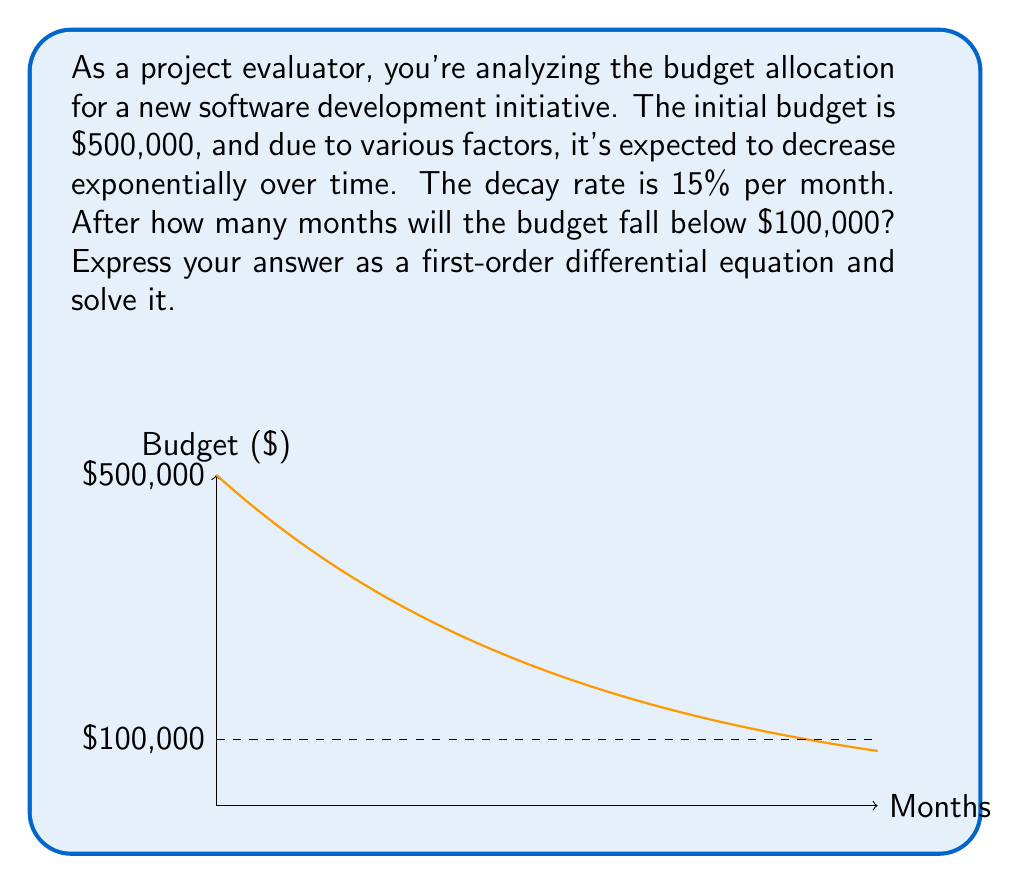Teach me how to tackle this problem. Let's approach this step-by-step:

1) Let $B(t)$ be the budget at time $t$ (in months). We know that $B(0) = 500,000$.

2) The rate of change of the budget is proportional to the current budget, with a decay rate of 15% per month. This can be expressed as a differential equation:

   $$\frac{dB}{dt} = -0.15B$$

3) This is a first-order linear differential equation. The general solution is:

   $$B(t) = Ce^{-0.15t}$$

   where $C$ is a constant we need to determine.

4) Using the initial condition $B(0) = 500,000$:

   $$500,000 = Ce^{-0.15(0)} = C$$

5) So, our specific solution is:

   $$B(t) = 500,000e^{-0.15t}$$

6) We want to find when $B(t) = 100,000$:

   $$100,000 = 500,000e^{-0.15t}$$

7) Dividing both sides by 500,000:

   $$0.2 = e^{-0.15t}$$

8) Taking the natural log of both sides:

   $$\ln(0.2) = -0.15t$$

9) Solving for $t$:

   $$t = -\frac{\ln(0.2)}{0.15} \approx 10.75$$

Therefore, the budget will fall below $100,000 after approximately 10.75 months.
Answer: $t = -\frac{\ln(0.2)}{0.15} \approx 10.75$ months 